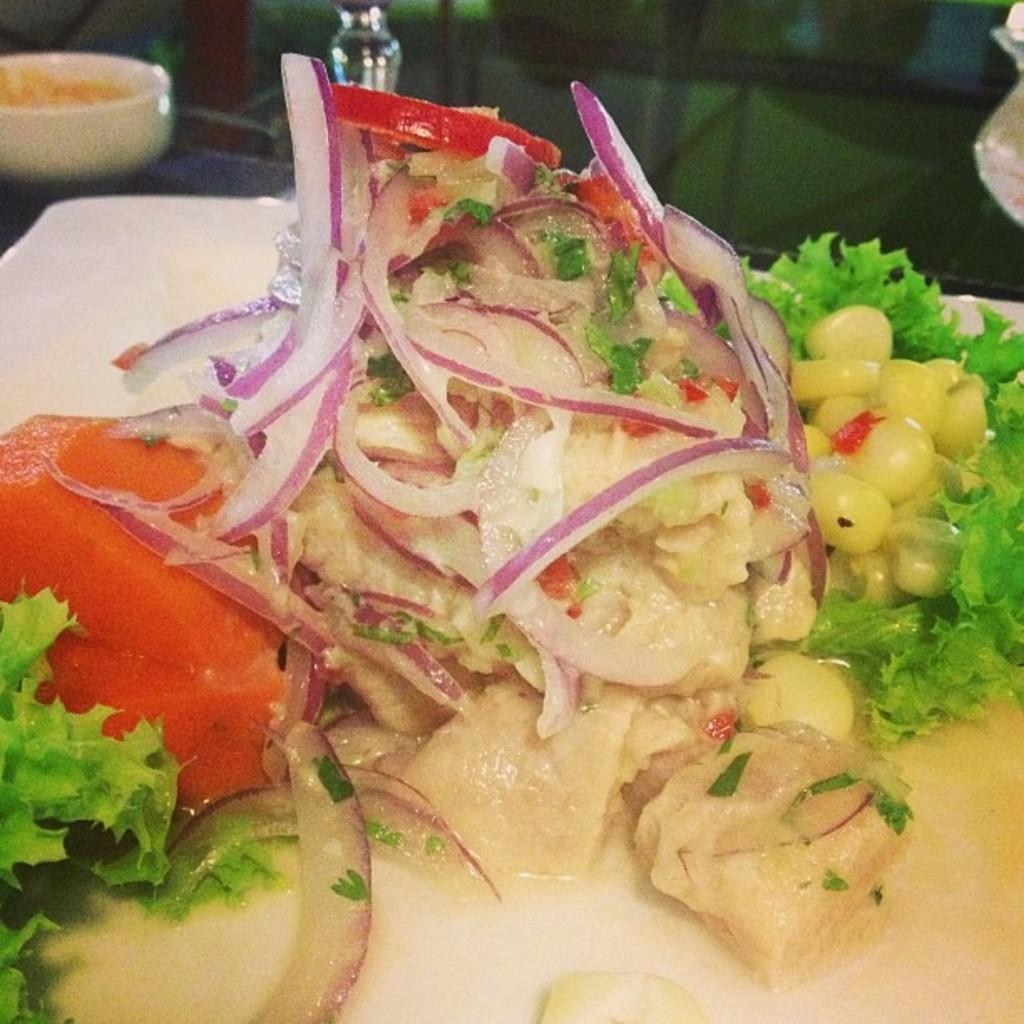What is the main subject in the center of the image? There is a plate of food item in the center of the image. Where is the plate located? The plate is on a table. What else can be seen in the image besides the plate? There is a bowl of food item in the top left corner of the image. How many eggs are being laid by the fowl in the image? There is no fowl or eggs present in the image. Is there a rainstorm occurring in the image? There is no indication of a rainstorm in the image. 